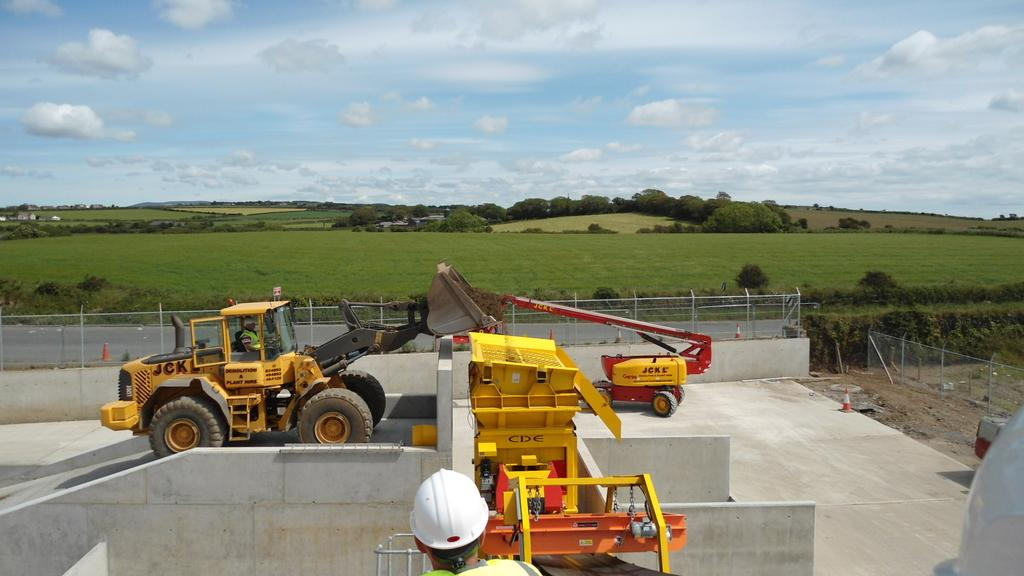What type of equipment can be seen in the image? There are construction machines in the image. What can be seen in the distance behind the construction machines? There is a field and trees in the background of the image. What is the condition of the sky in the image? The sky is cloudy in the background of the image. Where is the grandfather being held in the image? There is no grandfather or jail present in the image; it features construction machines and a background with a field, trees, and a cloudy sky. What type of soup is being served in the image? There is no soup present in the image. 